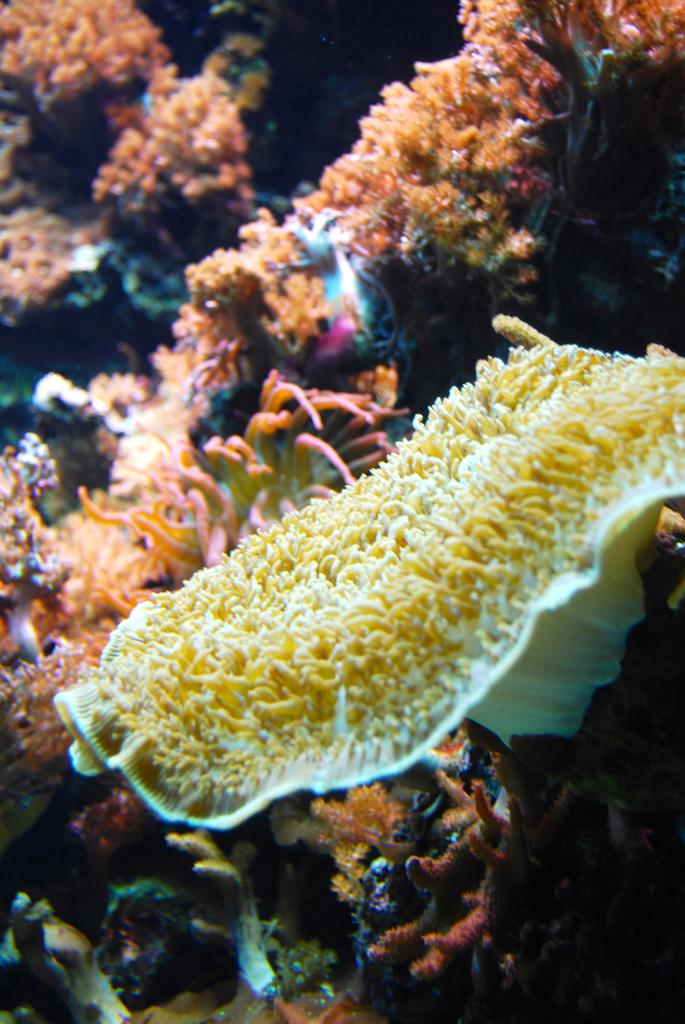Where is the faucet located in the image? Since there are no facts provided about the image, we cannot determine the presence or location of a faucet in the image. 